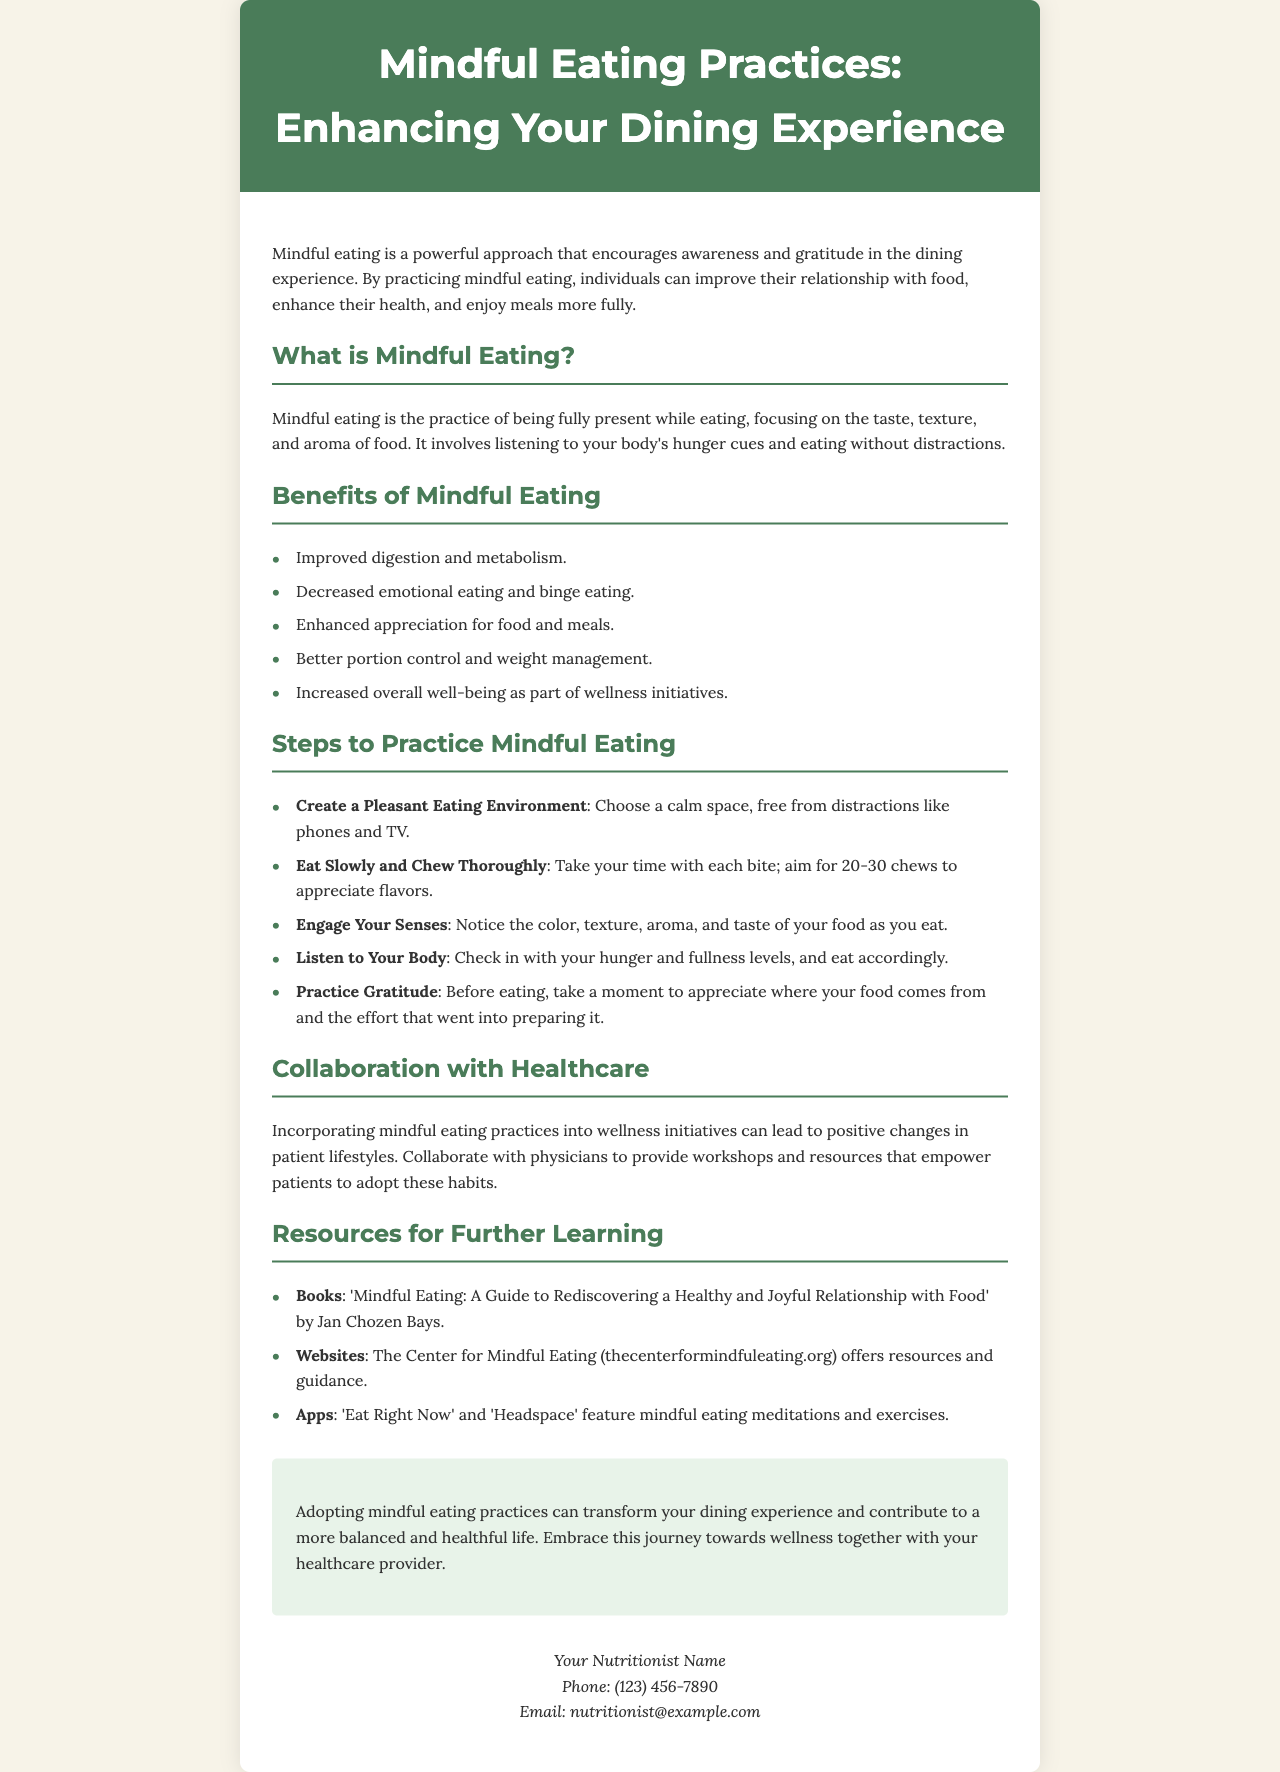What is the title of the brochure? The title of the brochure is presented prominently in the header section.
Answer: Mindful Eating Practices: Enhancing Your Dining Experience What are the benefits of mindful eating? The document lists multiple benefits in a section titled "Benefits of Mindful Eating."
Answer: Improved digestion and metabolism What is a step to practice mindful eating? The document outlines several steps in the section titled "Steps to Practice Mindful Eating."
Answer: Create a Pleasant Eating Environment Who can you collaborate with on wellness initiatives? The document mentions collaboration with healthcare providers in the section on "Collaboration with Healthcare."
Answer: Physicians What resource is recommended for further learning? The document includes a section titled "Resources for Further Learning" that suggests various resources.
Answer: The Center for Mindful Eating What is the recommended number of chews for each bite? The document specifies a range of chews to appreciate flavors in the "Steps to Practice Mindful Eating" section.
Answer: 20-30 chews What is the goal of practicing mindful eating? The document explains the overall aim of mindful eating in the introductory paragraph.
Answer: Improve relationship with food Who is the contact person listed in the brochure? The contact information section at the end of the document states the person's name.
Answer: Your Nutritionist Name 